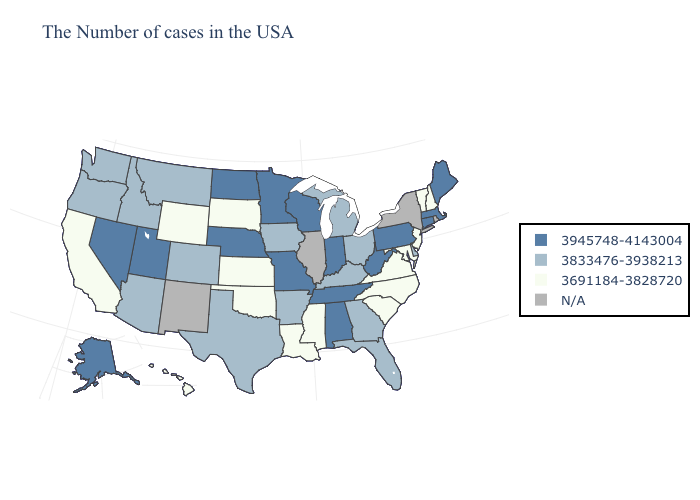Name the states that have a value in the range 3945748-4143004?
Short answer required. Maine, Massachusetts, Connecticut, Pennsylvania, West Virginia, Indiana, Alabama, Tennessee, Wisconsin, Missouri, Minnesota, Nebraska, North Dakota, Utah, Nevada, Alaska. What is the value of Nebraska?
Short answer required. 3945748-4143004. Name the states that have a value in the range N/A?
Keep it brief. Rhode Island, New York, Illinois, New Mexico. Among the states that border Arizona , does Utah have the lowest value?
Short answer required. No. What is the highest value in states that border Massachusetts?
Write a very short answer. 3945748-4143004. Among the states that border Oklahoma , which have the highest value?
Quick response, please. Missouri. Name the states that have a value in the range 3945748-4143004?
Give a very brief answer. Maine, Massachusetts, Connecticut, Pennsylvania, West Virginia, Indiana, Alabama, Tennessee, Wisconsin, Missouri, Minnesota, Nebraska, North Dakota, Utah, Nevada, Alaska. Among the states that border Wyoming , which have the highest value?
Concise answer only. Nebraska, Utah. Among the states that border Oregon , which have the highest value?
Quick response, please. Nevada. Does North Dakota have the lowest value in the USA?
Answer briefly. No. Which states have the lowest value in the USA?
Concise answer only. New Hampshire, Vermont, New Jersey, Maryland, Virginia, North Carolina, South Carolina, Mississippi, Louisiana, Kansas, Oklahoma, South Dakota, Wyoming, California, Hawaii. Which states have the lowest value in the USA?
Short answer required. New Hampshire, Vermont, New Jersey, Maryland, Virginia, North Carolina, South Carolina, Mississippi, Louisiana, Kansas, Oklahoma, South Dakota, Wyoming, California, Hawaii. Among the states that border Vermont , which have the lowest value?
Concise answer only. New Hampshire. Name the states that have a value in the range 3691184-3828720?
Give a very brief answer. New Hampshire, Vermont, New Jersey, Maryland, Virginia, North Carolina, South Carolina, Mississippi, Louisiana, Kansas, Oklahoma, South Dakota, Wyoming, California, Hawaii. 